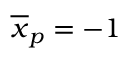Convert formula to latex. <formula><loc_0><loc_0><loc_500><loc_500>\overline { x } _ { p } = - 1</formula> 